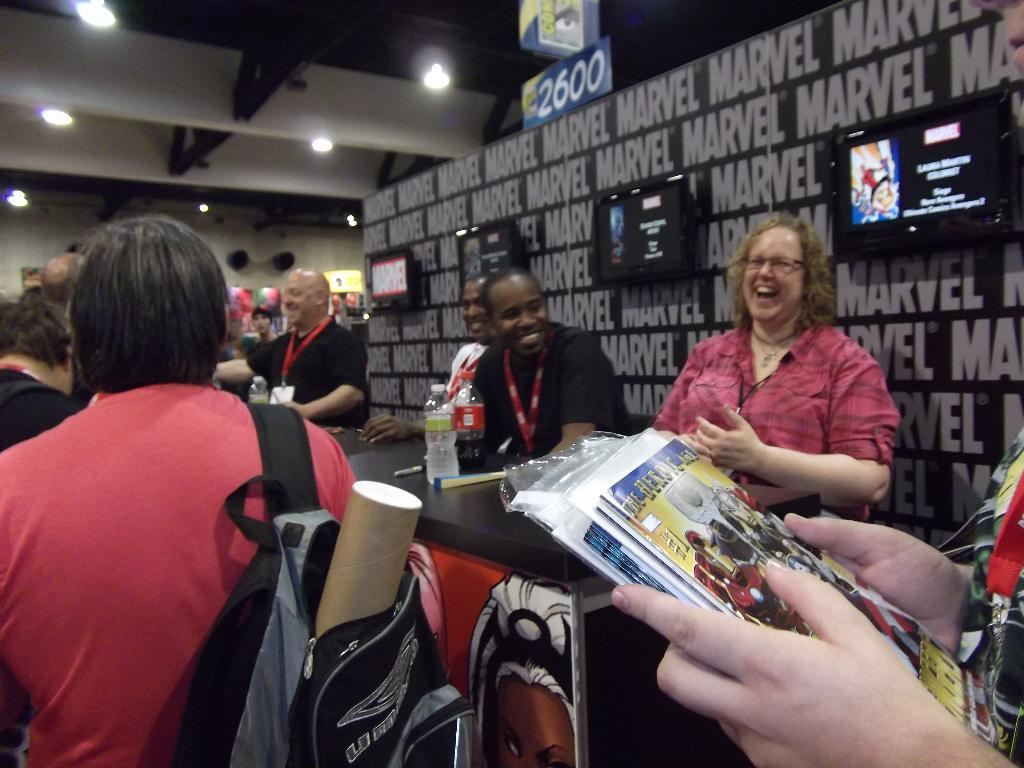Provide a one-sentence caption for the provided image. People in line at a Marvel signing event. 